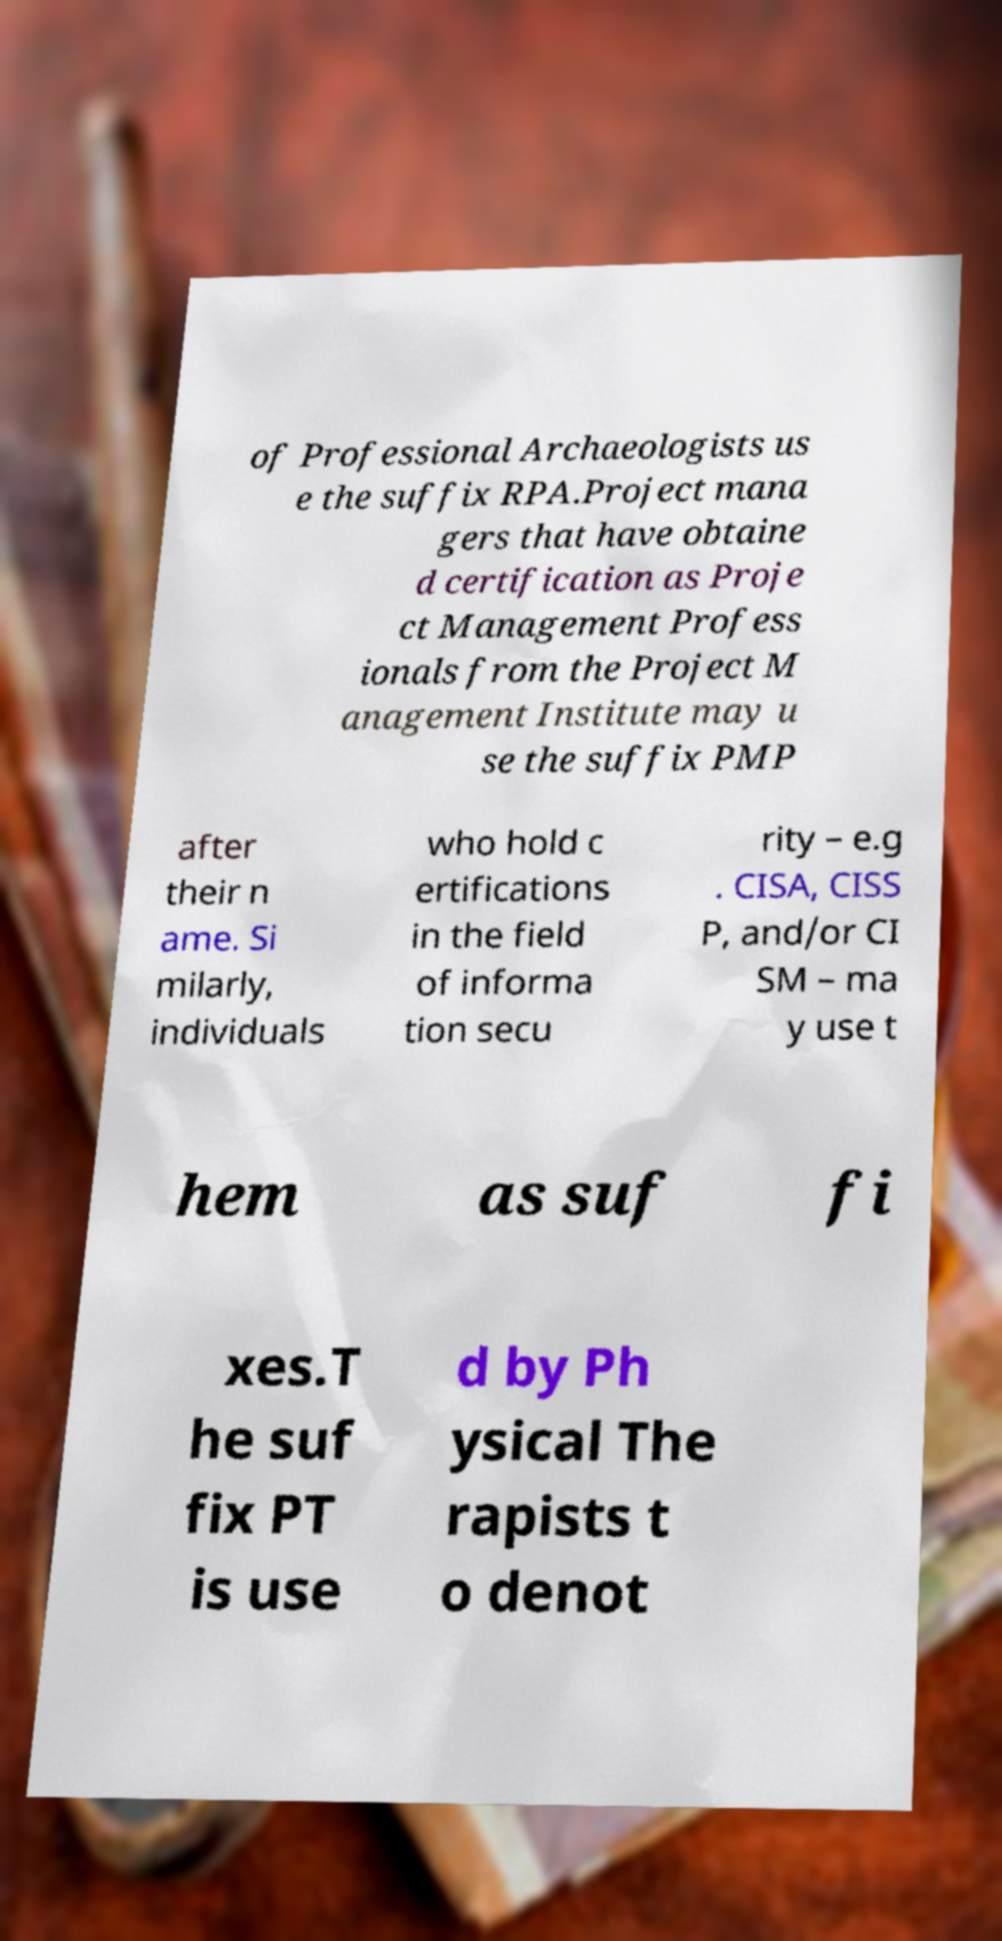What messages or text are displayed in this image? I need them in a readable, typed format. of Professional Archaeologists us e the suffix RPA.Project mana gers that have obtaine d certification as Proje ct Management Profess ionals from the Project M anagement Institute may u se the suffix PMP after their n ame. Si milarly, individuals who hold c ertifications in the field of informa tion secu rity – e.g . CISA, CISS P, and/or CI SM – ma y use t hem as suf fi xes.T he suf fix PT is use d by Ph ysical The rapists t o denot 